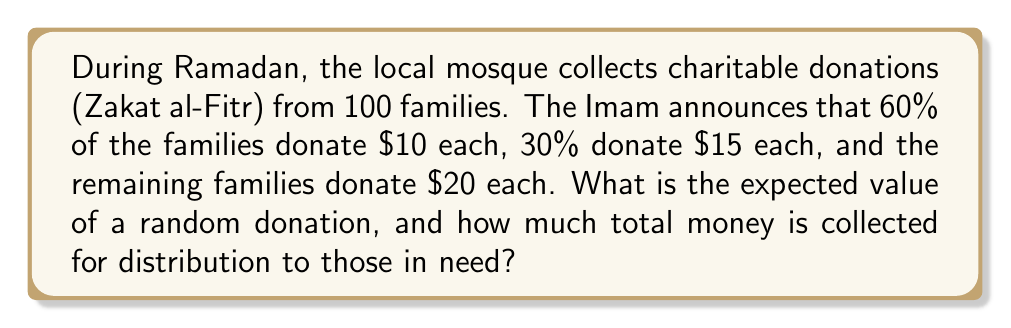Give your solution to this math problem. Let's approach this step-by-step:

1. First, we need to calculate the probabilities and values for each donation amount:
   - 60% of families donate $10: $p_1 = 0.60$, $v_1 = 10$
   - 30% of families donate $15: $p_2 = 0.30$, $v_2 = 15$
   - Remaining families (10%) donate $20: $p_3 = 0.10$, $v_3 = 20$

2. The expected value of a random donation is calculated using the formula:
   $$E(X) = \sum_{i=1}^n p_i v_i$$

3. Substituting our values:
   $$E(X) = (0.60 \times 10) + (0.30 \times 15) + (0.10 \times 20)$$

4. Calculating:
   $$E(X) = 6 + 4.5 + 2 = 12.5$$

5. To find the total money collected, we multiply the number of families by the expected value:
   $$\text{Total} = 100 \times E(X) = 100 \times 12.5 = 1250$$

Therefore, the expected value of a random donation is $12.50, and the total amount collected is $1250.
Answer: The expected value of a random donation is $12.50, and the total amount collected for distribution is $1250. 